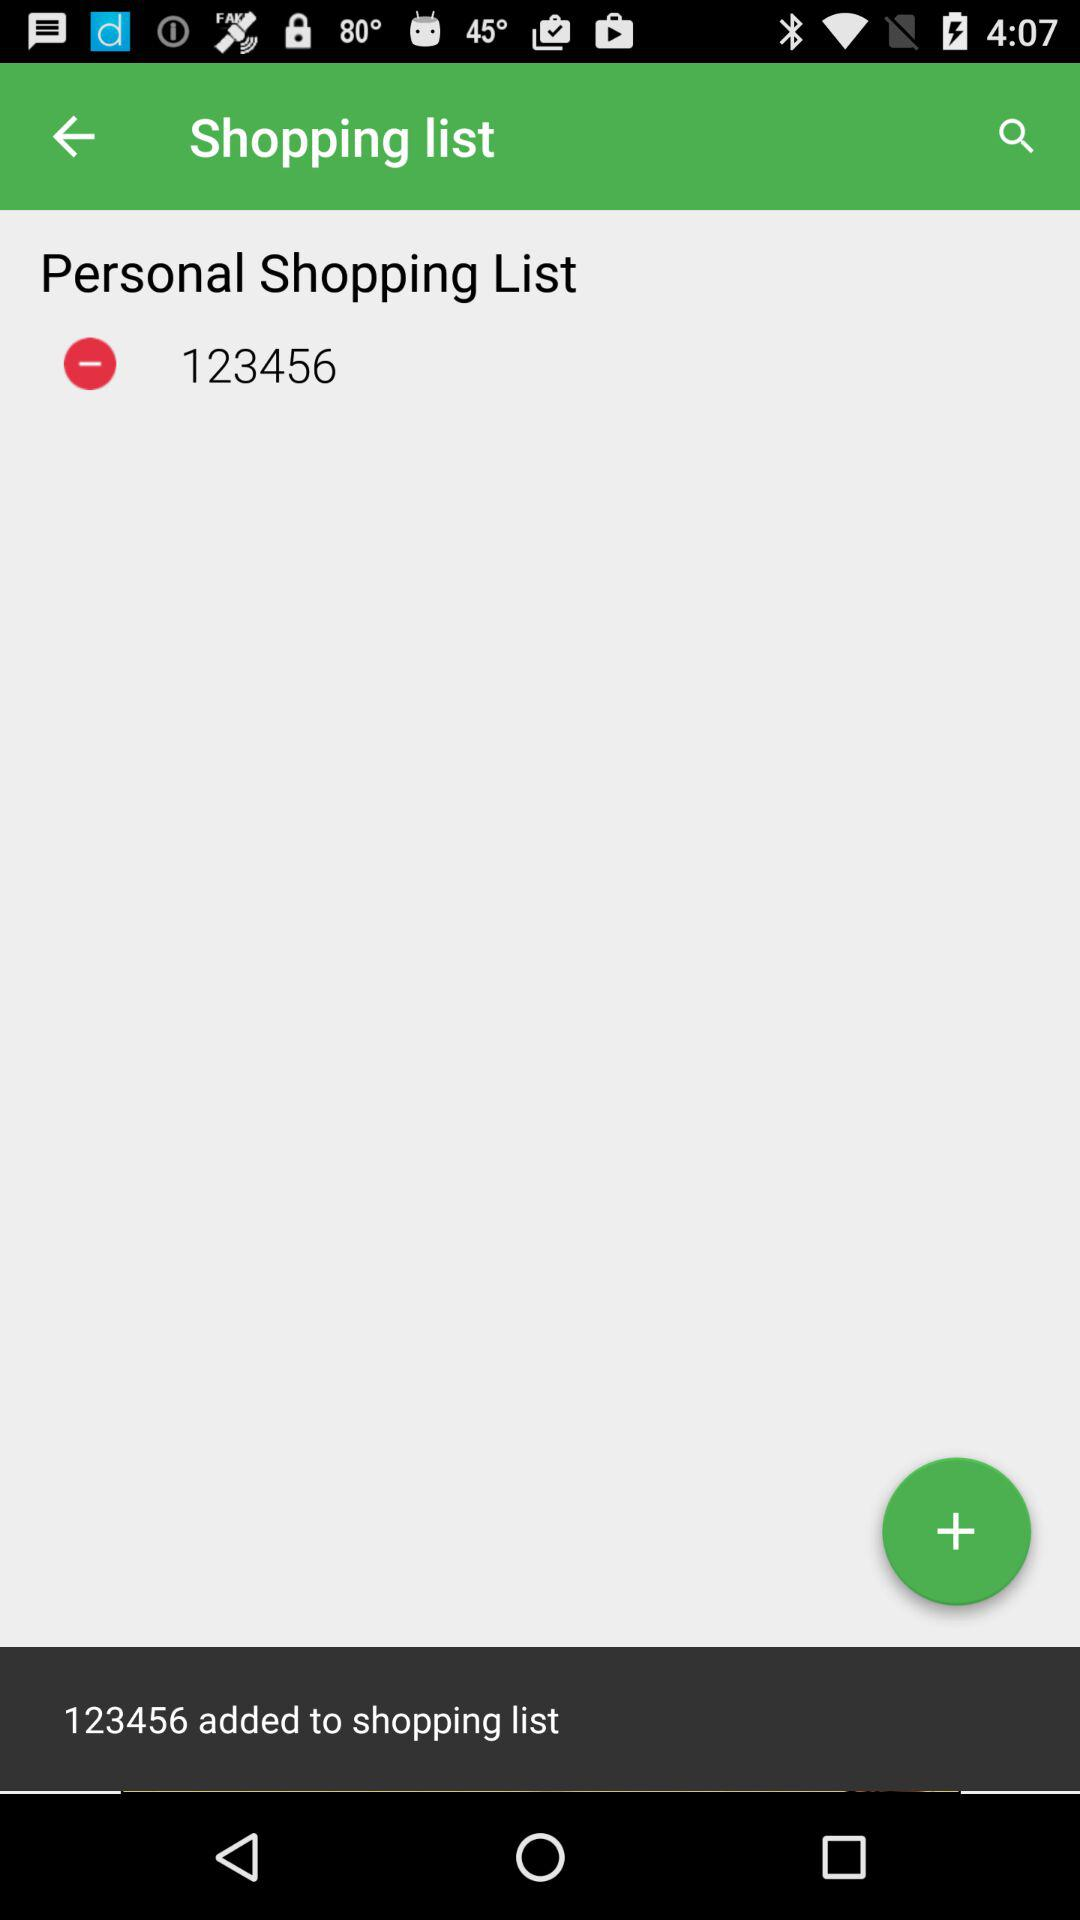What is added to the shopping list? To the shopping list, 123456 is added. 